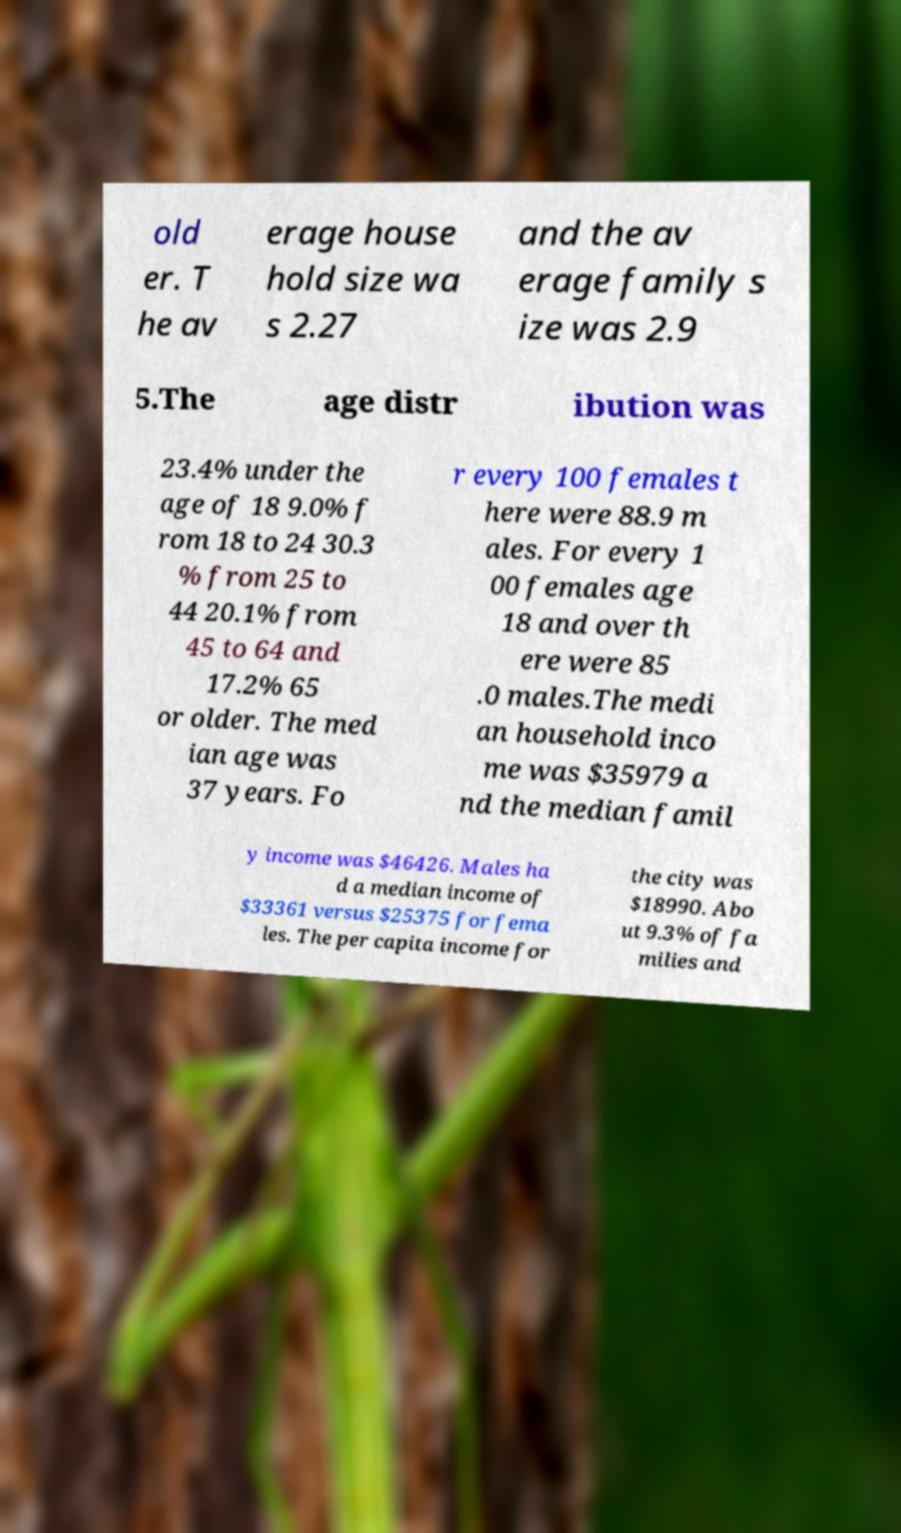Could you assist in decoding the text presented in this image and type it out clearly? old er. T he av erage house hold size wa s 2.27 and the av erage family s ize was 2.9 5.The age distr ibution was 23.4% under the age of 18 9.0% f rom 18 to 24 30.3 % from 25 to 44 20.1% from 45 to 64 and 17.2% 65 or older. The med ian age was 37 years. Fo r every 100 females t here were 88.9 m ales. For every 1 00 females age 18 and over th ere were 85 .0 males.The medi an household inco me was $35979 a nd the median famil y income was $46426. Males ha d a median income of $33361 versus $25375 for fema les. The per capita income for the city was $18990. Abo ut 9.3% of fa milies and 